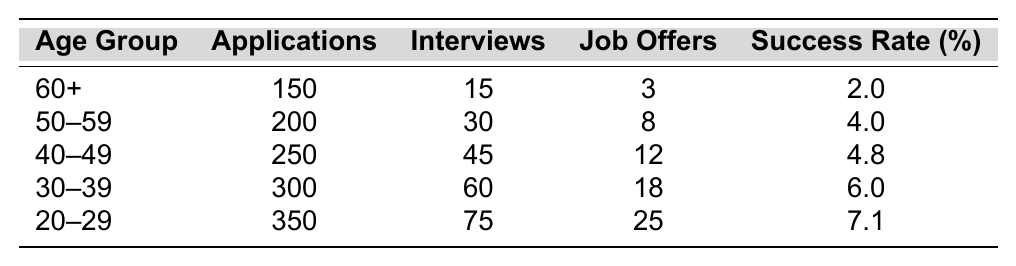What is the success rate for applicants aged 60 and above? The table shows that the success rate for the age group 60+ is listed as 2.0%.
Answer: 2.0% How many job offers did the 50-59 age group receive? By looking at the table, the 50-59 age group received 8 job offers.
Answer: 8 What is the total number of applications submitted by the 30-39 and 40-49 age groups combined? The 30-39 age group submitted 300 applications, and the 40-49 age group submitted 250 applications. Adding these gives a total of 300 + 250 = 550 applications submitted.
Answer: 550 Which age group has the highest success rate? The age group 20-29 has the highest success rate at 7.1%, compared to all other age groups in the table.
Answer: 20-29 Is the success rate for applicants aged 50-59 greater than that of applicants aged 40-49? The success rate for 50-59 is 4.0%, and for 40-49 it is 4.8%. Since 4.0% is less than 4.8%, the statement is false.
Answer: No How many more interviews did the 30-39 age group receive than the 60+ age group? The 30-39 age group received 60 interviews, and the 60+ age group received 15 interviews. The difference is 60 - 15 = 45 more interviews.
Answer: 45 What is the average success rate across all age groups represented in the table? To calculate the average success rate, sum the success rates: 2.0 + 4.0 + 4.8 + 6.0 + 7.1 = 24.9. Then divide by the number of age groups (5) which gives 24.9 / 5 = 4.98%.
Answer: 4.98% How many applications were submitted by the 20-29 age group? The table indicates that the 20-29 age group submitted 350 applications.
Answer: 350 What is the difference in job offers between the 40-49 and 50-59 age groups? The 40-49 age group received 12 job offers, while the 50-59 age group had 8. The difference is 12 - 8 = 4 job offers.
Answer: 4 Which age group has the least number of job offers? The least number of job offers is 3, which is attributed to the 60+ age group, making it the age group with the fewest job offers.
Answer: 60+ 